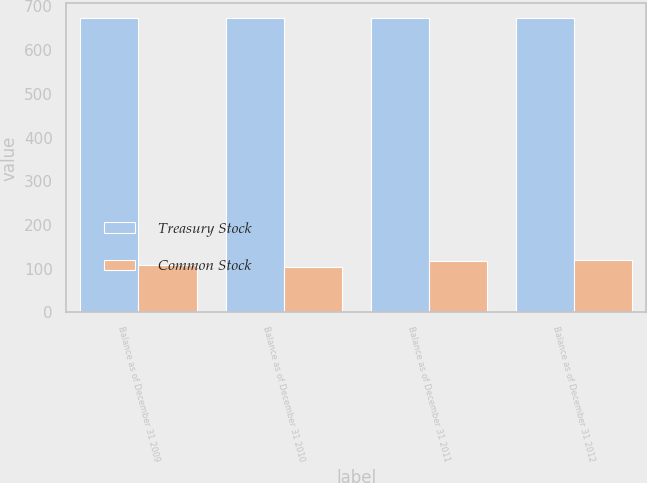Convert chart. <chart><loc_0><loc_0><loc_500><loc_500><stacked_bar_chart><ecel><fcel>Balance as of December 31 2009<fcel>Balance as of December 31 2010<fcel>Balance as of December 31 2011<fcel>Balance as of December 31 2012<nl><fcel>Treasury Stock<fcel>673<fcel>673<fcel>673<fcel>673<nl><fcel>Common Stock<fcel>109<fcel>105<fcel>117<fcel>121<nl></chart> 